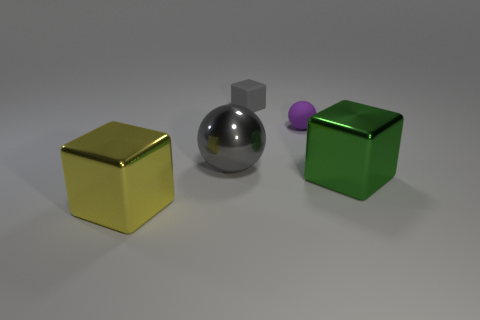Is the color of the tiny rubber cube the same as the big shiny sphere?
Your answer should be compact. Yes. There is a metallic block behind the large cube left of the large gray sphere; what number of gray metallic balls are in front of it?
Ensure brevity in your answer.  0. The green metallic object has what size?
Your answer should be compact. Large. There is a thing that is the same size as the matte sphere; what is its material?
Your response must be concise. Rubber. What number of gray cubes are to the left of the yellow thing?
Ensure brevity in your answer.  0. Does the cube that is in front of the big green metal cube have the same material as the block behind the green metallic block?
Provide a succinct answer. No. There is a large green object behind the large shiny cube that is in front of the large cube that is to the right of the big yellow metal block; what is its shape?
Provide a short and direct response. Cube. What shape is the green object?
Provide a succinct answer. Cube. What is the shape of the gray object that is the same size as the yellow metal cube?
Keep it short and to the point. Sphere. How many other objects are there of the same color as the matte ball?
Offer a terse response. 0. 